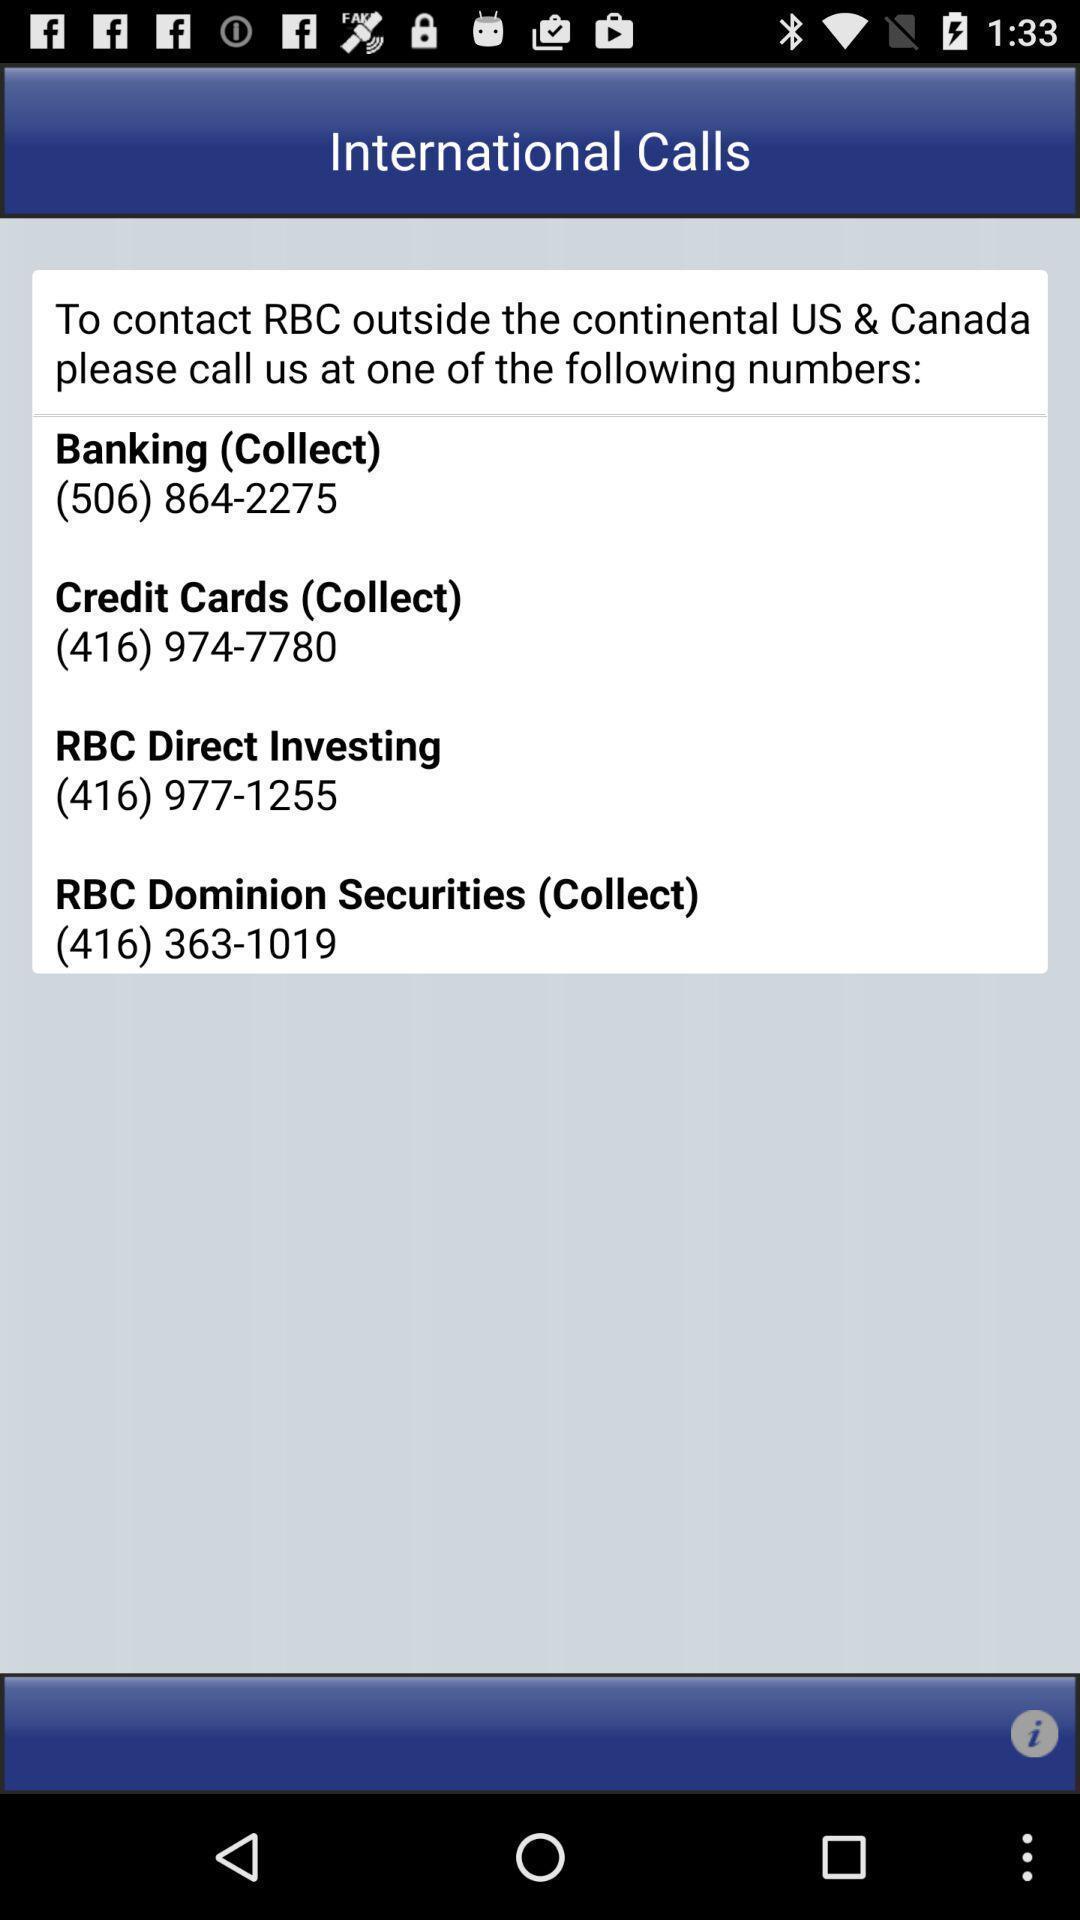Provide a textual representation of this image. Page showing various contact numbers. 